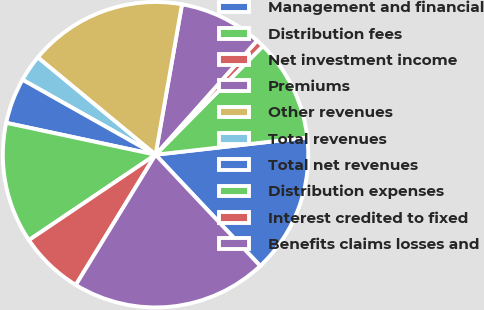<chart> <loc_0><loc_0><loc_500><loc_500><pie_chart><fcel>Management and financial<fcel>Distribution fees<fcel>Net investment income<fcel>Premiums<fcel>Other revenues<fcel>Total revenues<fcel>Total net revenues<fcel>Distribution expenses<fcel>Interest credited to fixed<fcel>Benefits claims losses and<nl><fcel>14.78%<fcel>10.8%<fcel>0.83%<fcel>8.8%<fcel>16.78%<fcel>2.82%<fcel>4.82%<fcel>12.79%<fcel>6.81%<fcel>20.76%<nl></chart> 